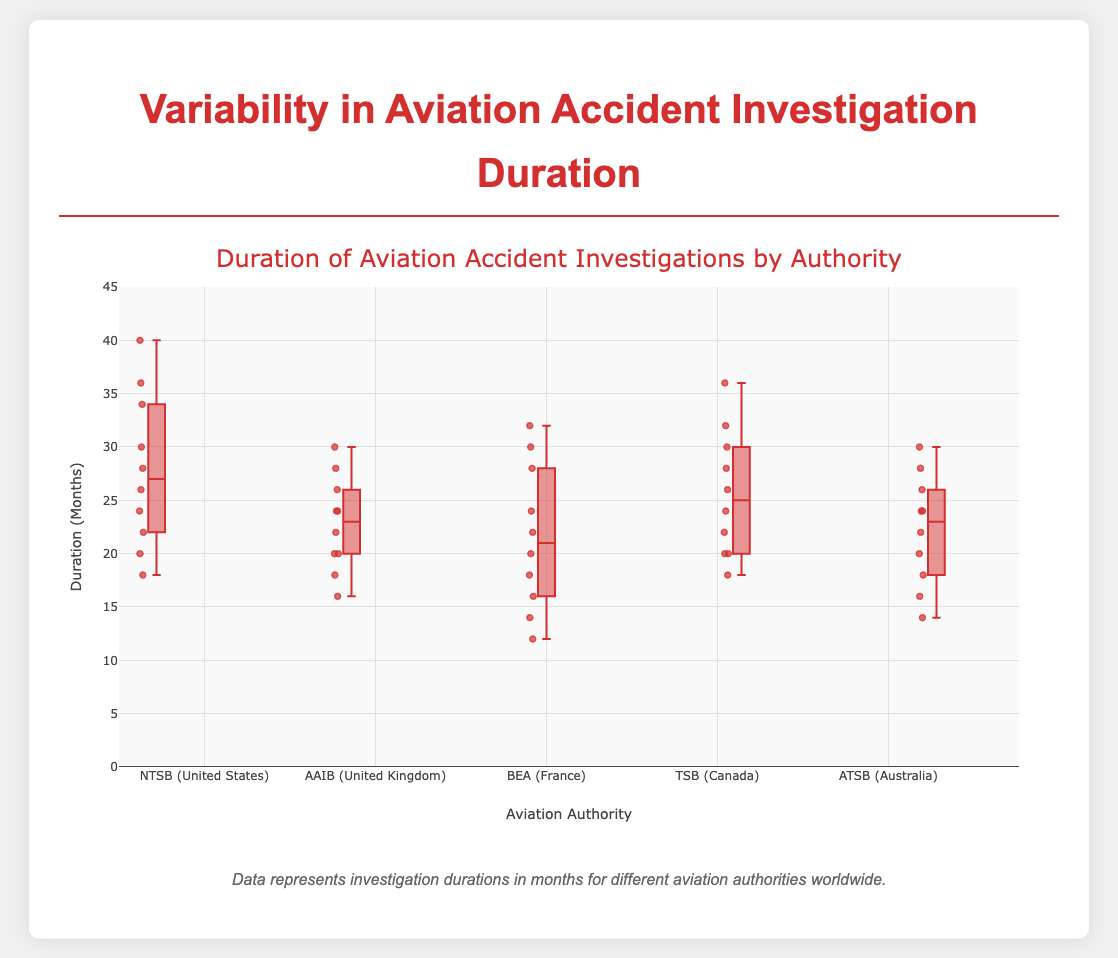What is the title of the figure? The title of the figure can be found at the top; it is the first piece of information usually present in any plot.
Answer: Duration of Aviation Accident Investigations by Authority Which authority has the median investigation duration closest to 24 months? In a box plot, the median line inside the box indicates the median value. By comparing the medians of each authority's box plot, we see that the AAIB and ATSB both have medians at 24 months.
Answer: AAIB and ATSB Which authority has the longest single investigation duration? Look at the individual points and the "whiskers" of the box plots. The longest single investigation duration is represented by the highest point in the box plot. The NTSB has the highest point at 40 months.
Answer: NTSB How does the variability in durations of AAIB investigations compare to that of NTSB? The variability is indicated by the length of the box and the whiskers. AAIB's whiskers and box are shorter, indicating less variability than the NTSB, which has a longer span of whiskers and a slightly larger box.
Answer: AAIB has less variability than NTSB Which authority's investigations have the shortest median duration? The median duration is indicated by the line inside the box. The BEA has the shortest median at around 20 months.
Answer: BEA What is the interquartile range (IQR) for TSB? The IQR is the difference between the upper quartile (75th percentile) and the lower quartile (25th percentile). For TSB, the box appears to span from ~20 to ~30 months, giving an IQR of 30 - 20 = 10 months.
Answer: 10 months Which authority has the smallest range of investigation durations? The range can be seen by looking at the distance from the smallest point to the largest point. The AAIB has the smallest range, from around 16 to 30 months.
Answer: AAIB Compare the median investigation durations of NTSB and ATSB. Look at the median line inside the boxes for NTSB and ATSB. The NTSB's median is at around 26 months, while ATSB's is at 24 months.
Answer: NTSB has a higher median duration than ATSB 